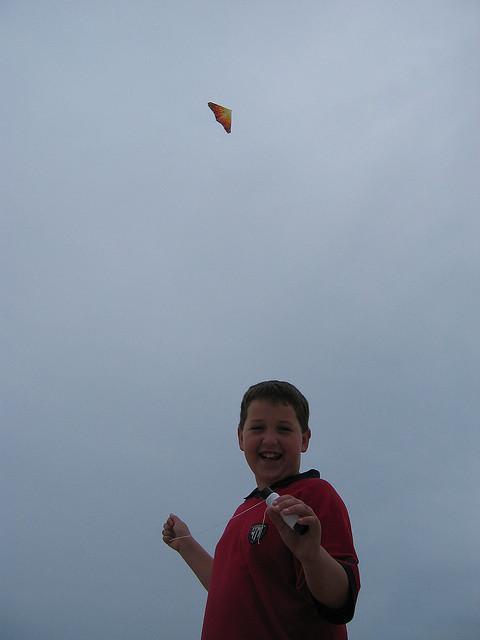How many strings is used to fly this kite?
Give a very brief answer. 1. How many people are there behind the man in red?
Give a very brief answer. 0. How many eyes are there?
Give a very brief answer. 2. How many clocks in the photo?
Give a very brief answer. 0. 